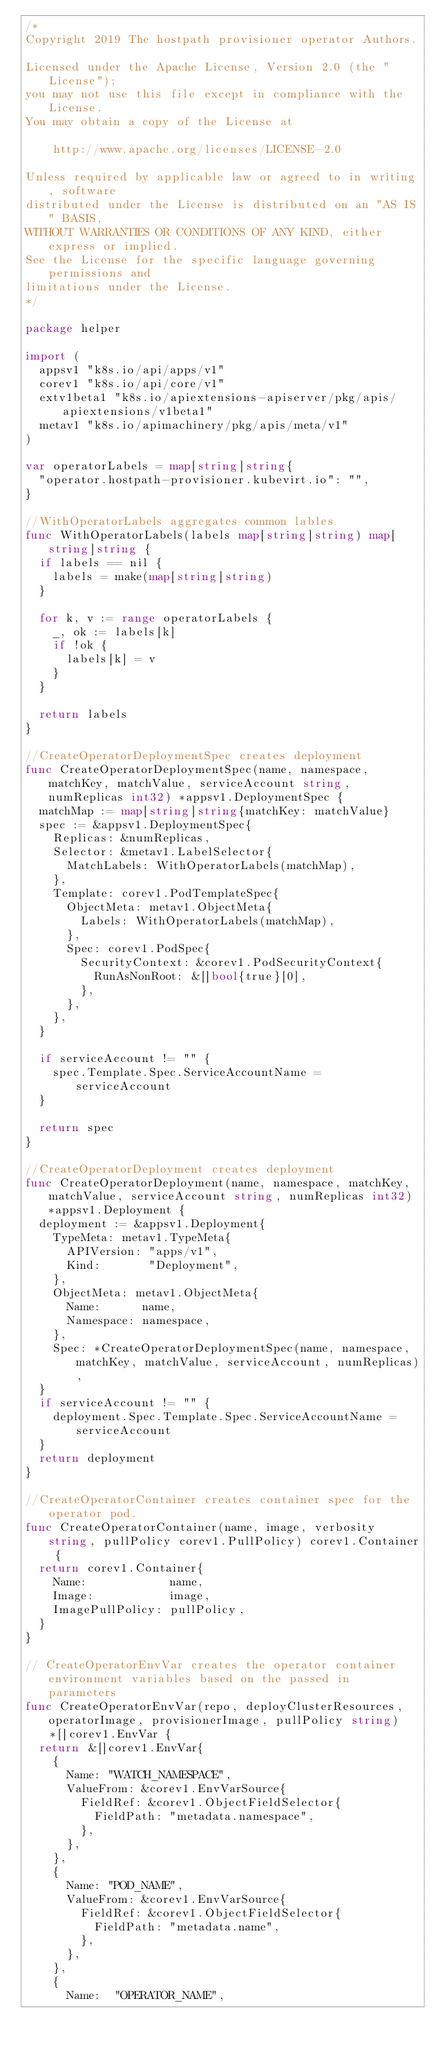<code> <loc_0><loc_0><loc_500><loc_500><_Go_>/*
Copyright 2019 The hostpath provisioner operator Authors.

Licensed under the Apache License, Version 2.0 (the "License");
you may not use this file except in compliance with the License.
You may obtain a copy of the License at

    http://www.apache.org/licenses/LICENSE-2.0

Unless required by applicable law or agreed to in writing, software
distributed under the License is distributed on an "AS IS" BASIS,
WITHOUT WARRANTIES OR CONDITIONS OF ANY KIND, either express or implied.
See the License for the specific language governing permissions and
limitations under the License.
*/

package helper

import (
	appsv1 "k8s.io/api/apps/v1"
	corev1 "k8s.io/api/core/v1"
	extv1beta1 "k8s.io/apiextensions-apiserver/pkg/apis/apiextensions/v1beta1"
	metav1 "k8s.io/apimachinery/pkg/apis/meta/v1"
)

var operatorLabels = map[string]string{
	"operator.hostpath-provisioner.kubevirt.io": "",
}

//WithOperatorLabels aggregates common lables
func WithOperatorLabels(labels map[string]string) map[string]string {
	if labels == nil {
		labels = make(map[string]string)
	}

	for k, v := range operatorLabels {
		_, ok := labels[k]
		if !ok {
			labels[k] = v
		}
	}

	return labels
}

//CreateOperatorDeploymentSpec creates deployment
func CreateOperatorDeploymentSpec(name, namespace, matchKey, matchValue, serviceAccount string, numReplicas int32) *appsv1.DeploymentSpec {
	matchMap := map[string]string{matchKey: matchValue}
	spec := &appsv1.DeploymentSpec{
		Replicas: &numReplicas,
		Selector: &metav1.LabelSelector{
			MatchLabels: WithOperatorLabels(matchMap),
		},
		Template: corev1.PodTemplateSpec{
			ObjectMeta: metav1.ObjectMeta{
				Labels: WithOperatorLabels(matchMap),
			},
			Spec: corev1.PodSpec{
				SecurityContext: &corev1.PodSecurityContext{
					RunAsNonRoot: &[]bool{true}[0],
				},
			},
		},
	}

	if serviceAccount != "" {
		spec.Template.Spec.ServiceAccountName = serviceAccount
	}

	return spec
}

//CreateOperatorDeployment creates deployment
func CreateOperatorDeployment(name, namespace, matchKey, matchValue, serviceAccount string, numReplicas int32) *appsv1.Deployment {
	deployment := &appsv1.Deployment{
		TypeMeta: metav1.TypeMeta{
			APIVersion: "apps/v1",
			Kind:       "Deployment",
		},
		ObjectMeta: metav1.ObjectMeta{
			Name:      name,
			Namespace: namespace,
		},
		Spec: *CreateOperatorDeploymentSpec(name, namespace, matchKey, matchValue, serviceAccount, numReplicas),
	}
	if serviceAccount != "" {
		deployment.Spec.Template.Spec.ServiceAccountName = serviceAccount
	}
	return deployment
}

//CreateOperatorContainer creates container spec for the operator pod.
func CreateOperatorContainer(name, image, verbosity string, pullPolicy corev1.PullPolicy) corev1.Container {
	return corev1.Container{
		Name:            name,
		Image:           image,
		ImagePullPolicy: pullPolicy,
	}
}

// CreateOperatorEnvVar creates the operator container environment variables based on the passed in parameters
func CreateOperatorEnvVar(repo, deployClusterResources, operatorImage, provisionerImage, pullPolicy string) *[]corev1.EnvVar {
	return &[]corev1.EnvVar{
		{
			Name: "WATCH_NAMESPACE",
			ValueFrom: &corev1.EnvVarSource{
				FieldRef: &corev1.ObjectFieldSelector{
					FieldPath: "metadata.namespace",
				},
			},
		},
		{
			Name: "POD_NAME",
			ValueFrom: &corev1.EnvVarSource{
				FieldRef: &corev1.ObjectFieldSelector{
					FieldPath: "metadata.name",
				},
			},
		},
		{
			Name:  "OPERATOR_NAME",</code> 